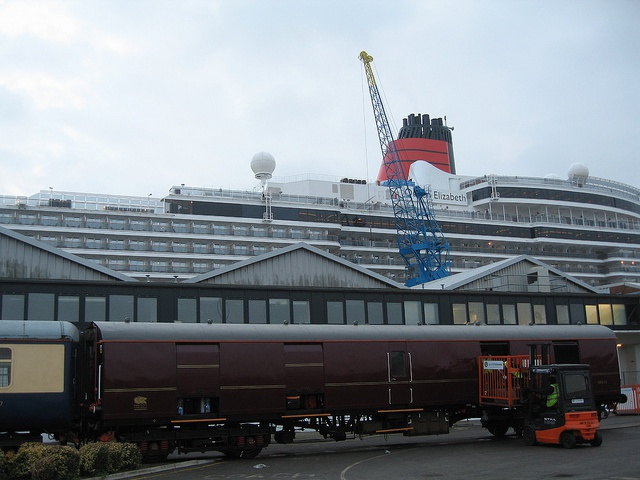Describe the objects in this image and their specific colors. I can see train in white, black, gray, maroon, and darkgray tones, truck in white, black, maroon, brown, and gray tones, and people in white, black, darkgreen, and green tones in this image. 